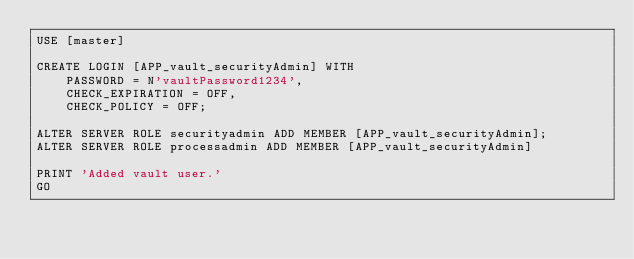<code> <loc_0><loc_0><loc_500><loc_500><_SQL_>USE [master]

CREATE LOGIN [APP_vault_securityAdmin] WITH 
	PASSWORD = N'vaultPassword1234',
	CHECK_EXPIRATION = OFF,
	CHECK_POLICY = OFF;

ALTER SERVER ROLE securityadmin ADD MEMBER [APP_vault_securityAdmin];
ALTER SERVER ROLE processadmin ADD MEMBER [APP_vault_securityAdmin]

PRINT 'Added vault user.'
GO</code> 